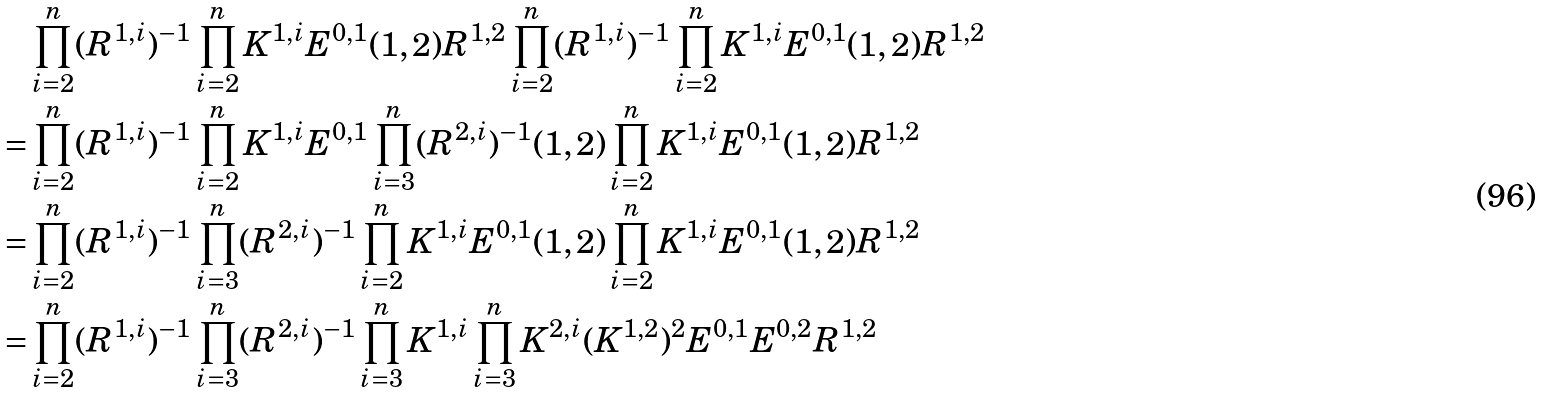Convert formula to latex. <formula><loc_0><loc_0><loc_500><loc_500>& \prod _ { i = 2 } ^ { n } ( R ^ { 1 , i } ) ^ { - 1 } \prod _ { i = 2 } ^ { n } K ^ { 1 , i } E ^ { 0 , 1 } ( 1 , 2 ) R ^ { 1 , 2 } \prod _ { i = 2 } ^ { n } ( R ^ { 1 , i } ) ^ { - 1 } \prod _ { i = 2 } ^ { n } K ^ { 1 , i } E ^ { 0 , 1 } ( 1 , 2 ) R ^ { 1 , 2 } \\ = & \prod _ { i = 2 } ^ { n } ( R ^ { 1 , i } ) ^ { - 1 } \prod _ { i = 2 } ^ { n } K ^ { 1 , i } E ^ { 0 , 1 } \prod _ { i = 3 } ^ { n } ( R ^ { 2 , i } ) ^ { - 1 } ( 1 , 2 ) \prod _ { i = 2 } ^ { n } K ^ { 1 , i } E ^ { 0 , 1 } ( 1 , 2 ) R ^ { 1 , 2 } \\ = & \prod _ { i = 2 } ^ { n } ( R ^ { 1 , i } ) ^ { - 1 } \prod _ { i = 3 } ^ { n } ( R ^ { 2 , i } ) ^ { - 1 } \prod _ { i = 2 } ^ { n } K ^ { 1 , i } E ^ { 0 , 1 } ( 1 , 2 ) \prod _ { i = 2 } ^ { n } K ^ { 1 , i } E ^ { 0 , 1 } ( 1 , 2 ) R ^ { 1 , 2 } \\ = & \prod _ { i = 2 } ^ { n } ( R ^ { 1 , i } ) ^ { - 1 } \prod _ { i = 3 } ^ { n } ( R ^ { 2 , i } ) ^ { - 1 } \prod _ { i = 3 } ^ { n } K ^ { 1 , i } \prod _ { i = 3 } ^ { n } K ^ { 2 , i } ( K ^ { 1 , 2 } ) ^ { 2 } E ^ { 0 , 1 } E ^ { 0 , 2 } R ^ { 1 , 2 } \\</formula> 